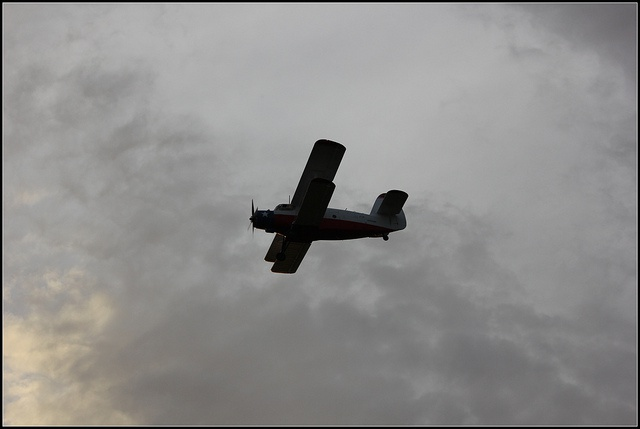Describe the objects in this image and their specific colors. I can see a airplane in black, darkgray, and gray tones in this image. 